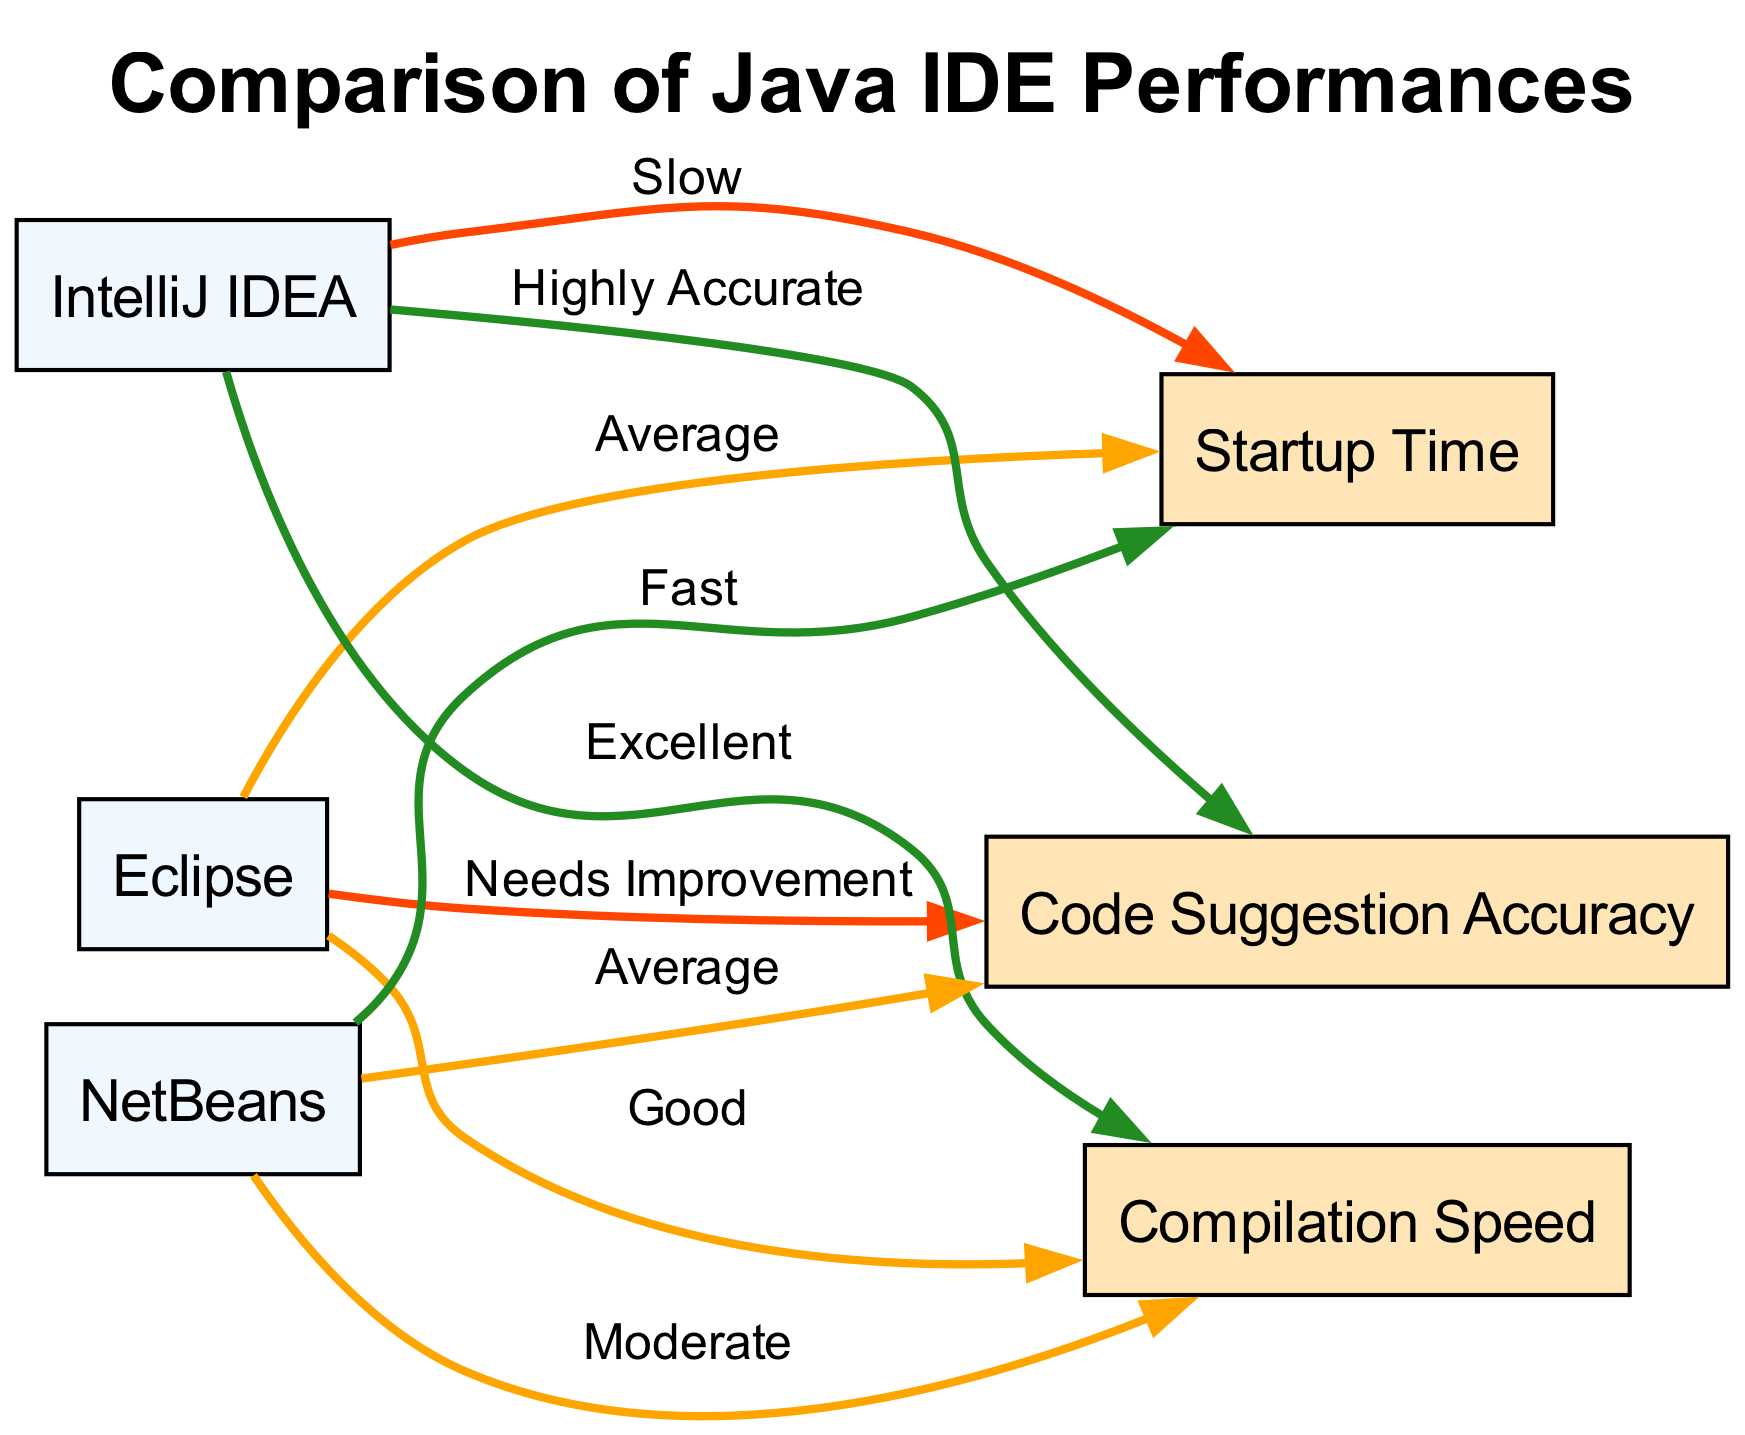What is the startup time rating for Eclipse? The diagram shows an edge from Eclipse to the Startup Time node labeled "Average". Therefore, the performance is rated as average for startup time.
Answer: Average Which IDE has the best compilation speed? By examining the edges, IntelliJ IDEA has an edge pointing to the Compilation Speed node labeled "Excellent", indicating it has the best speed for this metric among the provided IDEs.
Answer: Excellent How many IDEs are represented in the diagram? The diagram features three IDEs: Eclipse, IntelliJ IDEA, and NetBeans, which can be counted from the node list provided.
Answer: Three What is the suggestion accuracy for NetBeans? The edge from NetBeans to the Code Suggestion Accuracy node is labeled "Average". Thus, the suggestion accuracy for NetBeans is rated as average.
Answer: Average Which IDE has the slowest startup time? The edge from IntelliJ IDEA to the Startup Time node is marked as "Slow", making it the IDE with the slowest startup time compared to others in the diagram.
Answer: Slow What is the code suggestion accuracy for IntelliJ IDEA? The diagram indicates that the edge from IntelliJ IDEA to the Code Suggestion Accuracy node is labeled "Highly Accurate", showing its high accuracy for code suggestions.
Answer: Highly Accurate How is the compilation speed of Eclipse rated? The edge that connects Eclipse to the Compilation Speed node states "Good", representing its performance level in that category.
Answer: Good Which IDE has fast startup time? The node for NetBeans has an edge labeled "Fast" pointing to Startup Time, which signifies that it has a fast startup compared to the other options.
Answer: Fast What color represents the "Excellent" rating in the diagram? The edge for IntelliJ IDEA that connects to Compilation Speed is colored #228B22, which indicates an "Excellent" rating, showing a positive performance.
Answer: #228B22 